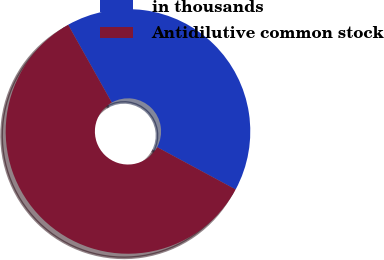<chart> <loc_0><loc_0><loc_500><loc_500><pie_chart><fcel>in thousands<fcel>Antidilutive common stock<nl><fcel>41.01%<fcel>58.99%<nl></chart> 